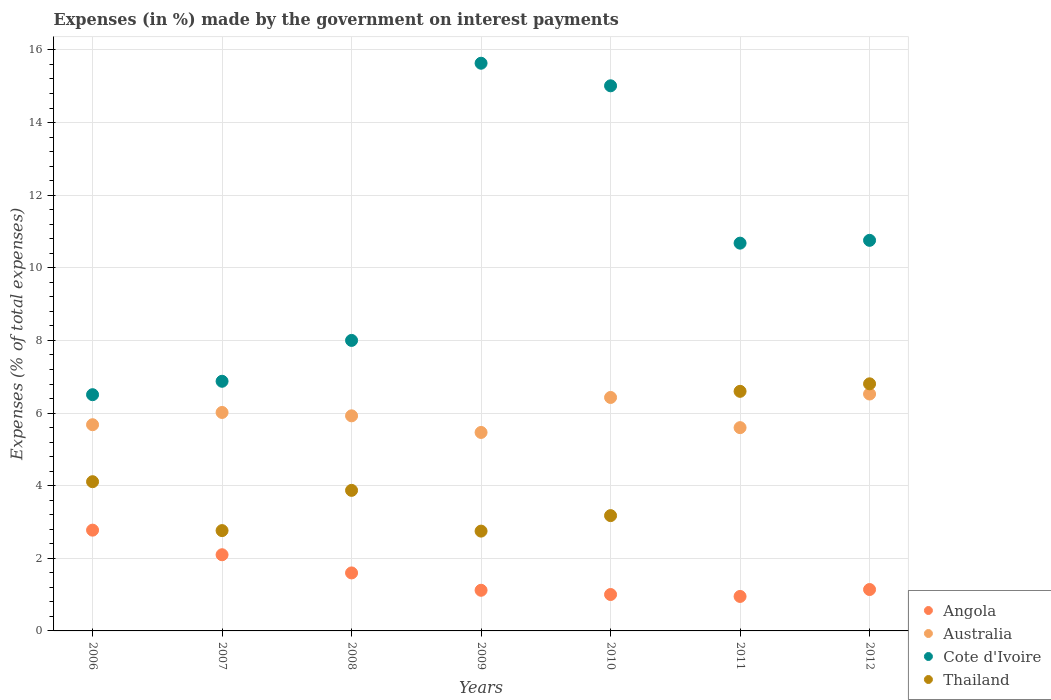How many different coloured dotlines are there?
Offer a terse response. 4. Is the number of dotlines equal to the number of legend labels?
Give a very brief answer. Yes. What is the percentage of expenses made by the government on interest payments in Thailand in 2007?
Ensure brevity in your answer.  2.76. Across all years, what is the maximum percentage of expenses made by the government on interest payments in Australia?
Provide a short and direct response. 6.52. Across all years, what is the minimum percentage of expenses made by the government on interest payments in Cote d'Ivoire?
Provide a succinct answer. 6.51. In which year was the percentage of expenses made by the government on interest payments in Cote d'Ivoire maximum?
Offer a very short reply. 2009. What is the total percentage of expenses made by the government on interest payments in Australia in the graph?
Make the answer very short. 41.64. What is the difference between the percentage of expenses made by the government on interest payments in Cote d'Ivoire in 2008 and that in 2011?
Offer a terse response. -2.68. What is the difference between the percentage of expenses made by the government on interest payments in Cote d'Ivoire in 2011 and the percentage of expenses made by the government on interest payments in Angola in 2012?
Your response must be concise. 9.54. What is the average percentage of expenses made by the government on interest payments in Thailand per year?
Provide a short and direct response. 4.3. In the year 2008, what is the difference between the percentage of expenses made by the government on interest payments in Angola and percentage of expenses made by the government on interest payments in Thailand?
Give a very brief answer. -2.27. In how many years, is the percentage of expenses made by the government on interest payments in Angola greater than 6.8 %?
Your answer should be very brief. 0. What is the ratio of the percentage of expenses made by the government on interest payments in Cote d'Ivoire in 2011 to that in 2012?
Ensure brevity in your answer.  0.99. What is the difference between the highest and the second highest percentage of expenses made by the government on interest payments in Cote d'Ivoire?
Ensure brevity in your answer.  0.62. What is the difference between the highest and the lowest percentage of expenses made by the government on interest payments in Cote d'Ivoire?
Give a very brief answer. 9.13. In how many years, is the percentage of expenses made by the government on interest payments in Thailand greater than the average percentage of expenses made by the government on interest payments in Thailand taken over all years?
Give a very brief answer. 2. Is it the case that in every year, the sum of the percentage of expenses made by the government on interest payments in Cote d'Ivoire and percentage of expenses made by the government on interest payments in Thailand  is greater than the sum of percentage of expenses made by the government on interest payments in Australia and percentage of expenses made by the government on interest payments in Angola?
Offer a very short reply. Yes. Does the percentage of expenses made by the government on interest payments in Australia monotonically increase over the years?
Your response must be concise. No. How many dotlines are there?
Give a very brief answer. 4. Are the values on the major ticks of Y-axis written in scientific E-notation?
Make the answer very short. No. What is the title of the graph?
Make the answer very short. Expenses (in %) made by the government on interest payments. Does "Angola" appear as one of the legend labels in the graph?
Your response must be concise. Yes. What is the label or title of the X-axis?
Give a very brief answer. Years. What is the label or title of the Y-axis?
Provide a short and direct response. Expenses (% of total expenses). What is the Expenses (% of total expenses) in Angola in 2006?
Keep it short and to the point. 2.78. What is the Expenses (% of total expenses) of Australia in 2006?
Keep it short and to the point. 5.68. What is the Expenses (% of total expenses) of Cote d'Ivoire in 2006?
Your response must be concise. 6.51. What is the Expenses (% of total expenses) in Thailand in 2006?
Your response must be concise. 4.11. What is the Expenses (% of total expenses) of Angola in 2007?
Your answer should be very brief. 2.1. What is the Expenses (% of total expenses) of Australia in 2007?
Ensure brevity in your answer.  6.02. What is the Expenses (% of total expenses) in Cote d'Ivoire in 2007?
Provide a short and direct response. 6.88. What is the Expenses (% of total expenses) of Thailand in 2007?
Offer a very short reply. 2.76. What is the Expenses (% of total expenses) of Angola in 2008?
Give a very brief answer. 1.6. What is the Expenses (% of total expenses) of Australia in 2008?
Ensure brevity in your answer.  5.92. What is the Expenses (% of total expenses) in Cote d'Ivoire in 2008?
Your answer should be compact. 8. What is the Expenses (% of total expenses) of Thailand in 2008?
Provide a succinct answer. 3.87. What is the Expenses (% of total expenses) of Angola in 2009?
Provide a short and direct response. 1.12. What is the Expenses (% of total expenses) in Australia in 2009?
Provide a short and direct response. 5.47. What is the Expenses (% of total expenses) in Cote d'Ivoire in 2009?
Make the answer very short. 15.63. What is the Expenses (% of total expenses) in Thailand in 2009?
Your answer should be compact. 2.75. What is the Expenses (% of total expenses) of Angola in 2010?
Provide a succinct answer. 1. What is the Expenses (% of total expenses) in Australia in 2010?
Ensure brevity in your answer.  6.43. What is the Expenses (% of total expenses) in Cote d'Ivoire in 2010?
Keep it short and to the point. 15.01. What is the Expenses (% of total expenses) of Thailand in 2010?
Ensure brevity in your answer.  3.18. What is the Expenses (% of total expenses) of Angola in 2011?
Your answer should be compact. 0.95. What is the Expenses (% of total expenses) in Australia in 2011?
Provide a succinct answer. 5.6. What is the Expenses (% of total expenses) of Cote d'Ivoire in 2011?
Offer a very short reply. 10.68. What is the Expenses (% of total expenses) of Thailand in 2011?
Make the answer very short. 6.6. What is the Expenses (% of total expenses) of Angola in 2012?
Keep it short and to the point. 1.14. What is the Expenses (% of total expenses) in Australia in 2012?
Give a very brief answer. 6.52. What is the Expenses (% of total expenses) of Cote d'Ivoire in 2012?
Make the answer very short. 10.76. What is the Expenses (% of total expenses) of Thailand in 2012?
Your answer should be compact. 6.81. Across all years, what is the maximum Expenses (% of total expenses) of Angola?
Keep it short and to the point. 2.78. Across all years, what is the maximum Expenses (% of total expenses) in Australia?
Offer a terse response. 6.52. Across all years, what is the maximum Expenses (% of total expenses) in Cote d'Ivoire?
Ensure brevity in your answer.  15.63. Across all years, what is the maximum Expenses (% of total expenses) in Thailand?
Keep it short and to the point. 6.81. Across all years, what is the minimum Expenses (% of total expenses) of Angola?
Provide a short and direct response. 0.95. Across all years, what is the minimum Expenses (% of total expenses) in Australia?
Give a very brief answer. 5.47. Across all years, what is the minimum Expenses (% of total expenses) in Cote d'Ivoire?
Your answer should be very brief. 6.51. Across all years, what is the minimum Expenses (% of total expenses) in Thailand?
Your response must be concise. 2.75. What is the total Expenses (% of total expenses) of Angola in the graph?
Your answer should be very brief. 10.68. What is the total Expenses (% of total expenses) of Australia in the graph?
Make the answer very short. 41.64. What is the total Expenses (% of total expenses) of Cote d'Ivoire in the graph?
Provide a short and direct response. 73.46. What is the total Expenses (% of total expenses) in Thailand in the graph?
Provide a short and direct response. 30.07. What is the difference between the Expenses (% of total expenses) of Angola in 2006 and that in 2007?
Offer a very short reply. 0.68. What is the difference between the Expenses (% of total expenses) of Australia in 2006 and that in 2007?
Make the answer very short. -0.34. What is the difference between the Expenses (% of total expenses) of Cote d'Ivoire in 2006 and that in 2007?
Give a very brief answer. -0.37. What is the difference between the Expenses (% of total expenses) of Thailand in 2006 and that in 2007?
Your answer should be compact. 1.35. What is the difference between the Expenses (% of total expenses) in Angola in 2006 and that in 2008?
Your answer should be compact. 1.18. What is the difference between the Expenses (% of total expenses) in Australia in 2006 and that in 2008?
Provide a succinct answer. -0.24. What is the difference between the Expenses (% of total expenses) in Cote d'Ivoire in 2006 and that in 2008?
Provide a short and direct response. -1.49. What is the difference between the Expenses (% of total expenses) in Thailand in 2006 and that in 2008?
Offer a very short reply. 0.24. What is the difference between the Expenses (% of total expenses) of Angola in 2006 and that in 2009?
Your response must be concise. 1.66. What is the difference between the Expenses (% of total expenses) of Australia in 2006 and that in 2009?
Your answer should be very brief. 0.21. What is the difference between the Expenses (% of total expenses) in Cote d'Ivoire in 2006 and that in 2009?
Provide a succinct answer. -9.13. What is the difference between the Expenses (% of total expenses) of Thailand in 2006 and that in 2009?
Your answer should be compact. 1.36. What is the difference between the Expenses (% of total expenses) in Angola in 2006 and that in 2010?
Provide a succinct answer. 1.77. What is the difference between the Expenses (% of total expenses) of Australia in 2006 and that in 2010?
Offer a very short reply. -0.75. What is the difference between the Expenses (% of total expenses) of Cote d'Ivoire in 2006 and that in 2010?
Keep it short and to the point. -8.51. What is the difference between the Expenses (% of total expenses) of Thailand in 2006 and that in 2010?
Your answer should be compact. 0.93. What is the difference between the Expenses (% of total expenses) of Angola in 2006 and that in 2011?
Your answer should be very brief. 1.83. What is the difference between the Expenses (% of total expenses) of Australia in 2006 and that in 2011?
Offer a very short reply. 0.08. What is the difference between the Expenses (% of total expenses) in Cote d'Ivoire in 2006 and that in 2011?
Ensure brevity in your answer.  -4.17. What is the difference between the Expenses (% of total expenses) of Thailand in 2006 and that in 2011?
Ensure brevity in your answer.  -2.49. What is the difference between the Expenses (% of total expenses) of Angola in 2006 and that in 2012?
Ensure brevity in your answer.  1.64. What is the difference between the Expenses (% of total expenses) in Australia in 2006 and that in 2012?
Keep it short and to the point. -0.85. What is the difference between the Expenses (% of total expenses) of Cote d'Ivoire in 2006 and that in 2012?
Make the answer very short. -4.25. What is the difference between the Expenses (% of total expenses) in Thailand in 2006 and that in 2012?
Ensure brevity in your answer.  -2.7. What is the difference between the Expenses (% of total expenses) in Angola in 2007 and that in 2008?
Provide a succinct answer. 0.5. What is the difference between the Expenses (% of total expenses) in Australia in 2007 and that in 2008?
Provide a short and direct response. 0.09. What is the difference between the Expenses (% of total expenses) in Cote d'Ivoire in 2007 and that in 2008?
Your answer should be very brief. -1.13. What is the difference between the Expenses (% of total expenses) of Thailand in 2007 and that in 2008?
Your answer should be very brief. -1.11. What is the difference between the Expenses (% of total expenses) in Angola in 2007 and that in 2009?
Make the answer very short. 0.98. What is the difference between the Expenses (% of total expenses) in Australia in 2007 and that in 2009?
Your answer should be very brief. 0.55. What is the difference between the Expenses (% of total expenses) in Cote d'Ivoire in 2007 and that in 2009?
Your answer should be very brief. -8.76. What is the difference between the Expenses (% of total expenses) of Thailand in 2007 and that in 2009?
Offer a terse response. 0.01. What is the difference between the Expenses (% of total expenses) of Angola in 2007 and that in 2010?
Give a very brief answer. 1.1. What is the difference between the Expenses (% of total expenses) of Australia in 2007 and that in 2010?
Your answer should be compact. -0.41. What is the difference between the Expenses (% of total expenses) of Cote d'Ivoire in 2007 and that in 2010?
Your response must be concise. -8.14. What is the difference between the Expenses (% of total expenses) of Thailand in 2007 and that in 2010?
Your response must be concise. -0.41. What is the difference between the Expenses (% of total expenses) in Angola in 2007 and that in 2011?
Offer a terse response. 1.15. What is the difference between the Expenses (% of total expenses) of Australia in 2007 and that in 2011?
Offer a very short reply. 0.42. What is the difference between the Expenses (% of total expenses) in Cote d'Ivoire in 2007 and that in 2011?
Offer a terse response. -3.8. What is the difference between the Expenses (% of total expenses) of Thailand in 2007 and that in 2011?
Ensure brevity in your answer.  -3.84. What is the difference between the Expenses (% of total expenses) in Angola in 2007 and that in 2012?
Offer a terse response. 0.96. What is the difference between the Expenses (% of total expenses) in Australia in 2007 and that in 2012?
Make the answer very short. -0.51. What is the difference between the Expenses (% of total expenses) of Cote d'Ivoire in 2007 and that in 2012?
Provide a short and direct response. -3.88. What is the difference between the Expenses (% of total expenses) of Thailand in 2007 and that in 2012?
Your answer should be compact. -4.04. What is the difference between the Expenses (% of total expenses) of Angola in 2008 and that in 2009?
Your answer should be compact. 0.48. What is the difference between the Expenses (% of total expenses) of Australia in 2008 and that in 2009?
Offer a very short reply. 0.46. What is the difference between the Expenses (% of total expenses) in Cote d'Ivoire in 2008 and that in 2009?
Your response must be concise. -7.63. What is the difference between the Expenses (% of total expenses) in Thailand in 2008 and that in 2009?
Ensure brevity in your answer.  1.12. What is the difference between the Expenses (% of total expenses) of Angola in 2008 and that in 2010?
Offer a terse response. 0.59. What is the difference between the Expenses (% of total expenses) of Australia in 2008 and that in 2010?
Your answer should be very brief. -0.51. What is the difference between the Expenses (% of total expenses) of Cote d'Ivoire in 2008 and that in 2010?
Your answer should be very brief. -7.01. What is the difference between the Expenses (% of total expenses) in Thailand in 2008 and that in 2010?
Your response must be concise. 0.7. What is the difference between the Expenses (% of total expenses) in Angola in 2008 and that in 2011?
Your answer should be compact. 0.65. What is the difference between the Expenses (% of total expenses) in Australia in 2008 and that in 2011?
Give a very brief answer. 0.33. What is the difference between the Expenses (% of total expenses) in Cote d'Ivoire in 2008 and that in 2011?
Give a very brief answer. -2.68. What is the difference between the Expenses (% of total expenses) in Thailand in 2008 and that in 2011?
Give a very brief answer. -2.73. What is the difference between the Expenses (% of total expenses) of Angola in 2008 and that in 2012?
Your response must be concise. 0.46. What is the difference between the Expenses (% of total expenses) of Australia in 2008 and that in 2012?
Your response must be concise. -0.6. What is the difference between the Expenses (% of total expenses) of Cote d'Ivoire in 2008 and that in 2012?
Give a very brief answer. -2.76. What is the difference between the Expenses (% of total expenses) of Thailand in 2008 and that in 2012?
Your answer should be very brief. -2.93. What is the difference between the Expenses (% of total expenses) in Angola in 2009 and that in 2010?
Keep it short and to the point. 0.12. What is the difference between the Expenses (% of total expenses) in Australia in 2009 and that in 2010?
Provide a succinct answer. -0.96. What is the difference between the Expenses (% of total expenses) of Cote d'Ivoire in 2009 and that in 2010?
Ensure brevity in your answer.  0.62. What is the difference between the Expenses (% of total expenses) in Thailand in 2009 and that in 2010?
Your answer should be very brief. -0.43. What is the difference between the Expenses (% of total expenses) in Angola in 2009 and that in 2011?
Your response must be concise. 0.17. What is the difference between the Expenses (% of total expenses) in Australia in 2009 and that in 2011?
Your answer should be very brief. -0.13. What is the difference between the Expenses (% of total expenses) of Cote d'Ivoire in 2009 and that in 2011?
Provide a succinct answer. 4.95. What is the difference between the Expenses (% of total expenses) of Thailand in 2009 and that in 2011?
Your response must be concise. -3.85. What is the difference between the Expenses (% of total expenses) of Angola in 2009 and that in 2012?
Your response must be concise. -0.02. What is the difference between the Expenses (% of total expenses) in Australia in 2009 and that in 2012?
Your answer should be very brief. -1.06. What is the difference between the Expenses (% of total expenses) in Cote d'Ivoire in 2009 and that in 2012?
Your response must be concise. 4.88. What is the difference between the Expenses (% of total expenses) in Thailand in 2009 and that in 2012?
Provide a short and direct response. -4.06. What is the difference between the Expenses (% of total expenses) of Angola in 2010 and that in 2011?
Provide a short and direct response. 0.05. What is the difference between the Expenses (% of total expenses) of Australia in 2010 and that in 2011?
Give a very brief answer. 0.83. What is the difference between the Expenses (% of total expenses) in Cote d'Ivoire in 2010 and that in 2011?
Provide a succinct answer. 4.33. What is the difference between the Expenses (% of total expenses) of Thailand in 2010 and that in 2011?
Your response must be concise. -3.42. What is the difference between the Expenses (% of total expenses) in Angola in 2010 and that in 2012?
Give a very brief answer. -0.14. What is the difference between the Expenses (% of total expenses) of Australia in 2010 and that in 2012?
Offer a very short reply. -0.1. What is the difference between the Expenses (% of total expenses) of Cote d'Ivoire in 2010 and that in 2012?
Your response must be concise. 4.26. What is the difference between the Expenses (% of total expenses) in Thailand in 2010 and that in 2012?
Provide a succinct answer. -3.63. What is the difference between the Expenses (% of total expenses) of Angola in 2011 and that in 2012?
Offer a terse response. -0.19. What is the difference between the Expenses (% of total expenses) in Australia in 2011 and that in 2012?
Your answer should be very brief. -0.93. What is the difference between the Expenses (% of total expenses) of Cote d'Ivoire in 2011 and that in 2012?
Offer a terse response. -0.08. What is the difference between the Expenses (% of total expenses) in Thailand in 2011 and that in 2012?
Give a very brief answer. -0.21. What is the difference between the Expenses (% of total expenses) of Angola in 2006 and the Expenses (% of total expenses) of Australia in 2007?
Your answer should be very brief. -3.24. What is the difference between the Expenses (% of total expenses) in Angola in 2006 and the Expenses (% of total expenses) in Cote d'Ivoire in 2007?
Give a very brief answer. -4.1. What is the difference between the Expenses (% of total expenses) in Angola in 2006 and the Expenses (% of total expenses) in Thailand in 2007?
Offer a very short reply. 0.01. What is the difference between the Expenses (% of total expenses) in Australia in 2006 and the Expenses (% of total expenses) in Cote d'Ivoire in 2007?
Your answer should be very brief. -1.2. What is the difference between the Expenses (% of total expenses) in Australia in 2006 and the Expenses (% of total expenses) in Thailand in 2007?
Make the answer very short. 2.92. What is the difference between the Expenses (% of total expenses) in Cote d'Ivoire in 2006 and the Expenses (% of total expenses) in Thailand in 2007?
Offer a very short reply. 3.74. What is the difference between the Expenses (% of total expenses) in Angola in 2006 and the Expenses (% of total expenses) in Australia in 2008?
Offer a terse response. -3.15. What is the difference between the Expenses (% of total expenses) of Angola in 2006 and the Expenses (% of total expenses) of Cote d'Ivoire in 2008?
Offer a very short reply. -5.23. What is the difference between the Expenses (% of total expenses) in Angola in 2006 and the Expenses (% of total expenses) in Thailand in 2008?
Your answer should be very brief. -1.1. What is the difference between the Expenses (% of total expenses) in Australia in 2006 and the Expenses (% of total expenses) in Cote d'Ivoire in 2008?
Your answer should be very brief. -2.32. What is the difference between the Expenses (% of total expenses) of Australia in 2006 and the Expenses (% of total expenses) of Thailand in 2008?
Give a very brief answer. 1.81. What is the difference between the Expenses (% of total expenses) of Cote d'Ivoire in 2006 and the Expenses (% of total expenses) of Thailand in 2008?
Make the answer very short. 2.63. What is the difference between the Expenses (% of total expenses) of Angola in 2006 and the Expenses (% of total expenses) of Australia in 2009?
Ensure brevity in your answer.  -2.69. What is the difference between the Expenses (% of total expenses) in Angola in 2006 and the Expenses (% of total expenses) in Cote d'Ivoire in 2009?
Ensure brevity in your answer.  -12.86. What is the difference between the Expenses (% of total expenses) in Angola in 2006 and the Expenses (% of total expenses) in Thailand in 2009?
Keep it short and to the point. 0.03. What is the difference between the Expenses (% of total expenses) in Australia in 2006 and the Expenses (% of total expenses) in Cote d'Ivoire in 2009?
Offer a very short reply. -9.96. What is the difference between the Expenses (% of total expenses) in Australia in 2006 and the Expenses (% of total expenses) in Thailand in 2009?
Give a very brief answer. 2.93. What is the difference between the Expenses (% of total expenses) in Cote d'Ivoire in 2006 and the Expenses (% of total expenses) in Thailand in 2009?
Provide a succinct answer. 3.76. What is the difference between the Expenses (% of total expenses) of Angola in 2006 and the Expenses (% of total expenses) of Australia in 2010?
Ensure brevity in your answer.  -3.65. What is the difference between the Expenses (% of total expenses) of Angola in 2006 and the Expenses (% of total expenses) of Cote d'Ivoire in 2010?
Your response must be concise. -12.24. What is the difference between the Expenses (% of total expenses) of Angola in 2006 and the Expenses (% of total expenses) of Thailand in 2010?
Provide a short and direct response. -0.4. What is the difference between the Expenses (% of total expenses) of Australia in 2006 and the Expenses (% of total expenses) of Cote d'Ivoire in 2010?
Your answer should be very brief. -9.33. What is the difference between the Expenses (% of total expenses) in Australia in 2006 and the Expenses (% of total expenses) in Thailand in 2010?
Keep it short and to the point. 2.5. What is the difference between the Expenses (% of total expenses) of Cote d'Ivoire in 2006 and the Expenses (% of total expenses) of Thailand in 2010?
Keep it short and to the point. 3.33. What is the difference between the Expenses (% of total expenses) in Angola in 2006 and the Expenses (% of total expenses) in Australia in 2011?
Offer a very short reply. -2.82. What is the difference between the Expenses (% of total expenses) of Angola in 2006 and the Expenses (% of total expenses) of Cote d'Ivoire in 2011?
Your answer should be very brief. -7.9. What is the difference between the Expenses (% of total expenses) of Angola in 2006 and the Expenses (% of total expenses) of Thailand in 2011?
Give a very brief answer. -3.82. What is the difference between the Expenses (% of total expenses) in Australia in 2006 and the Expenses (% of total expenses) in Cote d'Ivoire in 2011?
Offer a terse response. -5. What is the difference between the Expenses (% of total expenses) in Australia in 2006 and the Expenses (% of total expenses) in Thailand in 2011?
Give a very brief answer. -0.92. What is the difference between the Expenses (% of total expenses) in Cote d'Ivoire in 2006 and the Expenses (% of total expenses) in Thailand in 2011?
Offer a terse response. -0.09. What is the difference between the Expenses (% of total expenses) of Angola in 2006 and the Expenses (% of total expenses) of Australia in 2012?
Your answer should be very brief. -3.75. What is the difference between the Expenses (% of total expenses) in Angola in 2006 and the Expenses (% of total expenses) in Cote d'Ivoire in 2012?
Offer a terse response. -7.98. What is the difference between the Expenses (% of total expenses) in Angola in 2006 and the Expenses (% of total expenses) in Thailand in 2012?
Provide a short and direct response. -4.03. What is the difference between the Expenses (% of total expenses) of Australia in 2006 and the Expenses (% of total expenses) of Cote d'Ivoire in 2012?
Your answer should be very brief. -5.08. What is the difference between the Expenses (% of total expenses) of Australia in 2006 and the Expenses (% of total expenses) of Thailand in 2012?
Make the answer very short. -1.13. What is the difference between the Expenses (% of total expenses) in Cote d'Ivoire in 2006 and the Expenses (% of total expenses) in Thailand in 2012?
Offer a terse response. -0.3. What is the difference between the Expenses (% of total expenses) of Angola in 2007 and the Expenses (% of total expenses) of Australia in 2008?
Offer a very short reply. -3.83. What is the difference between the Expenses (% of total expenses) of Angola in 2007 and the Expenses (% of total expenses) of Cote d'Ivoire in 2008?
Keep it short and to the point. -5.9. What is the difference between the Expenses (% of total expenses) in Angola in 2007 and the Expenses (% of total expenses) in Thailand in 2008?
Your answer should be very brief. -1.77. What is the difference between the Expenses (% of total expenses) of Australia in 2007 and the Expenses (% of total expenses) of Cote d'Ivoire in 2008?
Your answer should be compact. -1.98. What is the difference between the Expenses (% of total expenses) of Australia in 2007 and the Expenses (% of total expenses) of Thailand in 2008?
Ensure brevity in your answer.  2.15. What is the difference between the Expenses (% of total expenses) in Cote d'Ivoire in 2007 and the Expenses (% of total expenses) in Thailand in 2008?
Keep it short and to the point. 3. What is the difference between the Expenses (% of total expenses) of Angola in 2007 and the Expenses (% of total expenses) of Australia in 2009?
Provide a short and direct response. -3.37. What is the difference between the Expenses (% of total expenses) in Angola in 2007 and the Expenses (% of total expenses) in Cote d'Ivoire in 2009?
Provide a short and direct response. -13.54. What is the difference between the Expenses (% of total expenses) of Angola in 2007 and the Expenses (% of total expenses) of Thailand in 2009?
Your answer should be compact. -0.65. What is the difference between the Expenses (% of total expenses) in Australia in 2007 and the Expenses (% of total expenses) in Cote d'Ivoire in 2009?
Your answer should be compact. -9.62. What is the difference between the Expenses (% of total expenses) of Australia in 2007 and the Expenses (% of total expenses) of Thailand in 2009?
Provide a succinct answer. 3.27. What is the difference between the Expenses (% of total expenses) of Cote d'Ivoire in 2007 and the Expenses (% of total expenses) of Thailand in 2009?
Provide a short and direct response. 4.13. What is the difference between the Expenses (% of total expenses) in Angola in 2007 and the Expenses (% of total expenses) in Australia in 2010?
Keep it short and to the point. -4.33. What is the difference between the Expenses (% of total expenses) in Angola in 2007 and the Expenses (% of total expenses) in Cote d'Ivoire in 2010?
Offer a very short reply. -12.91. What is the difference between the Expenses (% of total expenses) in Angola in 2007 and the Expenses (% of total expenses) in Thailand in 2010?
Ensure brevity in your answer.  -1.08. What is the difference between the Expenses (% of total expenses) of Australia in 2007 and the Expenses (% of total expenses) of Cote d'Ivoire in 2010?
Offer a very short reply. -9. What is the difference between the Expenses (% of total expenses) of Australia in 2007 and the Expenses (% of total expenses) of Thailand in 2010?
Ensure brevity in your answer.  2.84. What is the difference between the Expenses (% of total expenses) of Cote d'Ivoire in 2007 and the Expenses (% of total expenses) of Thailand in 2010?
Offer a very short reply. 3.7. What is the difference between the Expenses (% of total expenses) of Angola in 2007 and the Expenses (% of total expenses) of Australia in 2011?
Your response must be concise. -3.5. What is the difference between the Expenses (% of total expenses) of Angola in 2007 and the Expenses (% of total expenses) of Cote d'Ivoire in 2011?
Offer a terse response. -8.58. What is the difference between the Expenses (% of total expenses) of Angola in 2007 and the Expenses (% of total expenses) of Thailand in 2011?
Give a very brief answer. -4.5. What is the difference between the Expenses (% of total expenses) in Australia in 2007 and the Expenses (% of total expenses) in Cote d'Ivoire in 2011?
Your answer should be very brief. -4.66. What is the difference between the Expenses (% of total expenses) of Australia in 2007 and the Expenses (% of total expenses) of Thailand in 2011?
Your answer should be very brief. -0.58. What is the difference between the Expenses (% of total expenses) of Cote d'Ivoire in 2007 and the Expenses (% of total expenses) of Thailand in 2011?
Offer a very short reply. 0.28. What is the difference between the Expenses (% of total expenses) of Angola in 2007 and the Expenses (% of total expenses) of Australia in 2012?
Ensure brevity in your answer.  -4.43. What is the difference between the Expenses (% of total expenses) of Angola in 2007 and the Expenses (% of total expenses) of Cote d'Ivoire in 2012?
Give a very brief answer. -8.66. What is the difference between the Expenses (% of total expenses) in Angola in 2007 and the Expenses (% of total expenses) in Thailand in 2012?
Offer a terse response. -4.71. What is the difference between the Expenses (% of total expenses) of Australia in 2007 and the Expenses (% of total expenses) of Cote d'Ivoire in 2012?
Your answer should be compact. -4.74. What is the difference between the Expenses (% of total expenses) of Australia in 2007 and the Expenses (% of total expenses) of Thailand in 2012?
Your response must be concise. -0.79. What is the difference between the Expenses (% of total expenses) of Cote d'Ivoire in 2007 and the Expenses (% of total expenses) of Thailand in 2012?
Offer a terse response. 0.07. What is the difference between the Expenses (% of total expenses) of Angola in 2008 and the Expenses (% of total expenses) of Australia in 2009?
Offer a very short reply. -3.87. What is the difference between the Expenses (% of total expenses) in Angola in 2008 and the Expenses (% of total expenses) in Cote d'Ivoire in 2009?
Your answer should be compact. -14.04. What is the difference between the Expenses (% of total expenses) in Angola in 2008 and the Expenses (% of total expenses) in Thailand in 2009?
Offer a terse response. -1.15. What is the difference between the Expenses (% of total expenses) of Australia in 2008 and the Expenses (% of total expenses) of Cote d'Ivoire in 2009?
Offer a very short reply. -9.71. What is the difference between the Expenses (% of total expenses) of Australia in 2008 and the Expenses (% of total expenses) of Thailand in 2009?
Give a very brief answer. 3.17. What is the difference between the Expenses (% of total expenses) in Cote d'Ivoire in 2008 and the Expenses (% of total expenses) in Thailand in 2009?
Give a very brief answer. 5.25. What is the difference between the Expenses (% of total expenses) of Angola in 2008 and the Expenses (% of total expenses) of Australia in 2010?
Offer a terse response. -4.83. What is the difference between the Expenses (% of total expenses) of Angola in 2008 and the Expenses (% of total expenses) of Cote d'Ivoire in 2010?
Make the answer very short. -13.42. What is the difference between the Expenses (% of total expenses) in Angola in 2008 and the Expenses (% of total expenses) in Thailand in 2010?
Your answer should be compact. -1.58. What is the difference between the Expenses (% of total expenses) of Australia in 2008 and the Expenses (% of total expenses) of Cote d'Ivoire in 2010?
Your answer should be very brief. -9.09. What is the difference between the Expenses (% of total expenses) in Australia in 2008 and the Expenses (% of total expenses) in Thailand in 2010?
Make the answer very short. 2.75. What is the difference between the Expenses (% of total expenses) in Cote d'Ivoire in 2008 and the Expenses (% of total expenses) in Thailand in 2010?
Make the answer very short. 4.83. What is the difference between the Expenses (% of total expenses) in Angola in 2008 and the Expenses (% of total expenses) in Australia in 2011?
Your response must be concise. -4. What is the difference between the Expenses (% of total expenses) in Angola in 2008 and the Expenses (% of total expenses) in Cote d'Ivoire in 2011?
Offer a very short reply. -9.08. What is the difference between the Expenses (% of total expenses) in Angola in 2008 and the Expenses (% of total expenses) in Thailand in 2011?
Offer a very short reply. -5. What is the difference between the Expenses (% of total expenses) in Australia in 2008 and the Expenses (% of total expenses) in Cote d'Ivoire in 2011?
Ensure brevity in your answer.  -4.76. What is the difference between the Expenses (% of total expenses) of Australia in 2008 and the Expenses (% of total expenses) of Thailand in 2011?
Ensure brevity in your answer.  -0.67. What is the difference between the Expenses (% of total expenses) of Cote d'Ivoire in 2008 and the Expenses (% of total expenses) of Thailand in 2011?
Your answer should be compact. 1.4. What is the difference between the Expenses (% of total expenses) in Angola in 2008 and the Expenses (% of total expenses) in Australia in 2012?
Ensure brevity in your answer.  -4.93. What is the difference between the Expenses (% of total expenses) of Angola in 2008 and the Expenses (% of total expenses) of Cote d'Ivoire in 2012?
Offer a very short reply. -9.16. What is the difference between the Expenses (% of total expenses) in Angola in 2008 and the Expenses (% of total expenses) in Thailand in 2012?
Ensure brevity in your answer.  -5.21. What is the difference between the Expenses (% of total expenses) in Australia in 2008 and the Expenses (% of total expenses) in Cote d'Ivoire in 2012?
Your answer should be compact. -4.83. What is the difference between the Expenses (% of total expenses) of Australia in 2008 and the Expenses (% of total expenses) of Thailand in 2012?
Your answer should be very brief. -0.88. What is the difference between the Expenses (% of total expenses) of Cote d'Ivoire in 2008 and the Expenses (% of total expenses) of Thailand in 2012?
Your response must be concise. 1.2. What is the difference between the Expenses (% of total expenses) in Angola in 2009 and the Expenses (% of total expenses) in Australia in 2010?
Ensure brevity in your answer.  -5.31. What is the difference between the Expenses (% of total expenses) of Angola in 2009 and the Expenses (% of total expenses) of Cote d'Ivoire in 2010?
Offer a very short reply. -13.89. What is the difference between the Expenses (% of total expenses) of Angola in 2009 and the Expenses (% of total expenses) of Thailand in 2010?
Ensure brevity in your answer.  -2.06. What is the difference between the Expenses (% of total expenses) of Australia in 2009 and the Expenses (% of total expenses) of Cote d'Ivoire in 2010?
Your response must be concise. -9.55. What is the difference between the Expenses (% of total expenses) of Australia in 2009 and the Expenses (% of total expenses) of Thailand in 2010?
Provide a short and direct response. 2.29. What is the difference between the Expenses (% of total expenses) in Cote d'Ivoire in 2009 and the Expenses (% of total expenses) in Thailand in 2010?
Your answer should be very brief. 12.46. What is the difference between the Expenses (% of total expenses) of Angola in 2009 and the Expenses (% of total expenses) of Australia in 2011?
Your response must be concise. -4.48. What is the difference between the Expenses (% of total expenses) in Angola in 2009 and the Expenses (% of total expenses) in Cote d'Ivoire in 2011?
Your response must be concise. -9.56. What is the difference between the Expenses (% of total expenses) in Angola in 2009 and the Expenses (% of total expenses) in Thailand in 2011?
Keep it short and to the point. -5.48. What is the difference between the Expenses (% of total expenses) of Australia in 2009 and the Expenses (% of total expenses) of Cote d'Ivoire in 2011?
Your answer should be very brief. -5.21. What is the difference between the Expenses (% of total expenses) in Australia in 2009 and the Expenses (% of total expenses) in Thailand in 2011?
Give a very brief answer. -1.13. What is the difference between the Expenses (% of total expenses) in Cote d'Ivoire in 2009 and the Expenses (% of total expenses) in Thailand in 2011?
Offer a terse response. 9.04. What is the difference between the Expenses (% of total expenses) of Angola in 2009 and the Expenses (% of total expenses) of Australia in 2012?
Give a very brief answer. -5.41. What is the difference between the Expenses (% of total expenses) in Angola in 2009 and the Expenses (% of total expenses) in Cote d'Ivoire in 2012?
Offer a very short reply. -9.64. What is the difference between the Expenses (% of total expenses) of Angola in 2009 and the Expenses (% of total expenses) of Thailand in 2012?
Offer a terse response. -5.69. What is the difference between the Expenses (% of total expenses) of Australia in 2009 and the Expenses (% of total expenses) of Cote d'Ivoire in 2012?
Provide a succinct answer. -5.29. What is the difference between the Expenses (% of total expenses) of Australia in 2009 and the Expenses (% of total expenses) of Thailand in 2012?
Your response must be concise. -1.34. What is the difference between the Expenses (% of total expenses) of Cote d'Ivoire in 2009 and the Expenses (% of total expenses) of Thailand in 2012?
Offer a very short reply. 8.83. What is the difference between the Expenses (% of total expenses) of Angola in 2010 and the Expenses (% of total expenses) of Australia in 2011?
Offer a very short reply. -4.6. What is the difference between the Expenses (% of total expenses) of Angola in 2010 and the Expenses (% of total expenses) of Cote d'Ivoire in 2011?
Your response must be concise. -9.68. What is the difference between the Expenses (% of total expenses) in Angola in 2010 and the Expenses (% of total expenses) in Thailand in 2011?
Keep it short and to the point. -5.6. What is the difference between the Expenses (% of total expenses) of Australia in 2010 and the Expenses (% of total expenses) of Cote d'Ivoire in 2011?
Make the answer very short. -4.25. What is the difference between the Expenses (% of total expenses) in Australia in 2010 and the Expenses (% of total expenses) in Thailand in 2011?
Keep it short and to the point. -0.17. What is the difference between the Expenses (% of total expenses) in Cote d'Ivoire in 2010 and the Expenses (% of total expenses) in Thailand in 2011?
Offer a very short reply. 8.41. What is the difference between the Expenses (% of total expenses) of Angola in 2010 and the Expenses (% of total expenses) of Australia in 2012?
Make the answer very short. -5.52. What is the difference between the Expenses (% of total expenses) of Angola in 2010 and the Expenses (% of total expenses) of Cote d'Ivoire in 2012?
Your answer should be very brief. -9.75. What is the difference between the Expenses (% of total expenses) of Angola in 2010 and the Expenses (% of total expenses) of Thailand in 2012?
Offer a very short reply. -5.8. What is the difference between the Expenses (% of total expenses) in Australia in 2010 and the Expenses (% of total expenses) in Cote d'Ivoire in 2012?
Provide a short and direct response. -4.33. What is the difference between the Expenses (% of total expenses) in Australia in 2010 and the Expenses (% of total expenses) in Thailand in 2012?
Provide a succinct answer. -0.38. What is the difference between the Expenses (% of total expenses) of Cote d'Ivoire in 2010 and the Expenses (% of total expenses) of Thailand in 2012?
Make the answer very short. 8.21. What is the difference between the Expenses (% of total expenses) in Angola in 2011 and the Expenses (% of total expenses) in Australia in 2012?
Your answer should be compact. -5.57. What is the difference between the Expenses (% of total expenses) of Angola in 2011 and the Expenses (% of total expenses) of Cote d'Ivoire in 2012?
Offer a terse response. -9.81. What is the difference between the Expenses (% of total expenses) of Angola in 2011 and the Expenses (% of total expenses) of Thailand in 2012?
Make the answer very short. -5.86. What is the difference between the Expenses (% of total expenses) in Australia in 2011 and the Expenses (% of total expenses) in Cote d'Ivoire in 2012?
Offer a very short reply. -5.16. What is the difference between the Expenses (% of total expenses) in Australia in 2011 and the Expenses (% of total expenses) in Thailand in 2012?
Ensure brevity in your answer.  -1.21. What is the difference between the Expenses (% of total expenses) in Cote d'Ivoire in 2011 and the Expenses (% of total expenses) in Thailand in 2012?
Your answer should be very brief. 3.87. What is the average Expenses (% of total expenses) of Angola per year?
Offer a terse response. 1.53. What is the average Expenses (% of total expenses) in Australia per year?
Your answer should be compact. 5.95. What is the average Expenses (% of total expenses) in Cote d'Ivoire per year?
Your answer should be compact. 10.49. What is the average Expenses (% of total expenses) in Thailand per year?
Make the answer very short. 4.3. In the year 2006, what is the difference between the Expenses (% of total expenses) in Angola and Expenses (% of total expenses) in Australia?
Your answer should be very brief. -2.9. In the year 2006, what is the difference between the Expenses (% of total expenses) in Angola and Expenses (% of total expenses) in Cote d'Ivoire?
Give a very brief answer. -3.73. In the year 2006, what is the difference between the Expenses (% of total expenses) of Angola and Expenses (% of total expenses) of Thailand?
Your response must be concise. -1.33. In the year 2006, what is the difference between the Expenses (% of total expenses) in Australia and Expenses (% of total expenses) in Cote d'Ivoire?
Provide a succinct answer. -0.83. In the year 2006, what is the difference between the Expenses (% of total expenses) of Australia and Expenses (% of total expenses) of Thailand?
Ensure brevity in your answer.  1.57. In the year 2006, what is the difference between the Expenses (% of total expenses) of Cote d'Ivoire and Expenses (% of total expenses) of Thailand?
Make the answer very short. 2.4. In the year 2007, what is the difference between the Expenses (% of total expenses) of Angola and Expenses (% of total expenses) of Australia?
Give a very brief answer. -3.92. In the year 2007, what is the difference between the Expenses (% of total expenses) in Angola and Expenses (% of total expenses) in Cote d'Ivoire?
Offer a very short reply. -4.78. In the year 2007, what is the difference between the Expenses (% of total expenses) in Angola and Expenses (% of total expenses) in Thailand?
Provide a succinct answer. -0.67. In the year 2007, what is the difference between the Expenses (% of total expenses) of Australia and Expenses (% of total expenses) of Cote d'Ivoire?
Your answer should be very brief. -0.86. In the year 2007, what is the difference between the Expenses (% of total expenses) of Australia and Expenses (% of total expenses) of Thailand?
Offer a terse response. 3.25. In the year 2007, what is the difference between the Expenses (% of total expenses) of Cote d'Ivoire and Expenses (% of total expenses) of Thailand?
Your answer should be very brief. 4.11. In the year 2008, what is the difference between the Expenses (% of total expenses) in Angola and Expenses (% of total expenses) in Australia?
Your answer should be compact. -4.33. In the year 2008, what is the difference between the Expenses (% of total expenses) in Angola and Expenses (% of total expenses) in Cote d'Ivoire?
Give a very brief answer. -6.4. In the year 2008, what is the difference between the Expenses (% of total expenses) of Angola and Expenses (% of total expenses) of Thailand?
Offer a terse response. -2.27. In the year 2008, what is the difference between the Expenses (% of total expenses) of Australia and Expenses (% of total expenses) of Cote d'Ivoire?
Offer a terse response. -2.08. In the year 2008, what is the difference between the Expenses (% of total expenses) of Australia and Expenses (% of total expenses) of Thailand?
Your answer should be very brief. 2.05. In the year 2008, what is the difference between the Expenses (% of total expenses) in Cote d'Ivoire and Expenses (% of total expenses) in Thailand?
Keep it short and to the point. 4.13. In the year 2009, what is the difference between the Expenses (% of total expenses) of Angola and Expenses (% of total expenses) of Australia?
Keep it short and to the point. -4.35. In the year 2009, what is the difference between the Expenses (% of total expenses) in Angola and Expenses (% of total expenses) in Cote d'Ivoire?
Make the answer very short. -14.51. In the year 2009, what is the difference between the Expenses (% of total expenses) of Angola and Expenses (% of total expenses) of Thailand?
Give a very brief answer. -1.63. In the year 2009, what is the difference between the Expenses (% of total expenses) in Australia and Expenses (% of total expenses) in Cote d'Ivoire?
Your answer should be very brief. -10.17. In the year 2009, what is the difference between the Expenses (% of total expenses) of Australia and Expenses (% of total expenses) of Thailand?
Offer a terse response. 2.72. In the year 2009, what is the difference between the Expenses (% of total expenses) in Cote d'Ivoire and Expenses (% of total expenses) in Thailand?
Provide a short and direct response. 12.89. In the year 2010, what is the difference between the Expenses (% of total expenses) of Angola and Expenses (% of total expenses) of Australia?
Keep it short and to the point. -5.43. In the year 2010, what is the difference between the Expenses (% of total expenses) in Angola and Expenses (% of total expenses) in Cote d'Ivoire?
Give a very brief answer. -14.01. In the year 2010, what is the difference between the Expenses (% of total expenses) in Angola and Expenses (% of total expenses) in Thailand?
Ensure brevity in your answer.  -2.17. In the year 2010, what is the difference between the Expenses (% of total expenses) in Australia and Expenses (% of total expenses) in Cote d'Ivoire?
Provide a short and direct response. -8.58. In the year 2010, what is the difference between the Expenses (% of total expenses) of Australia and Expenses (% of total expenses) of Thailand?
Offer a very short reply. 3.25. In the year 2010, what is the difference between the Expenses (% of total expenses) of Cote d'Ivoire and Expenses (% of total expenses) of Thailand?
Ensure brevity in your answer.  11.84. In the year 2011, what is the difference between the Expenses (% of total expenses) of Angola and Expenses (% of total expenses) of Australia?
Give a very brief answer. -4.65. In the year 2011, what is the difference between the Expenses (% of total expenses) in Angola and Expenses (% of total expenses) in Cote d'Ivoire?
Keep it short and to the point. -9.73. In the year 2011, what is the difference between the Expenses (% of total expenses) of Angola and Expenses (% of total expenses) of Thailand?
Ensure brevity in your answer.  -5.65. In the year 2011, what is the difference between the Expenses (% of total expenses) in Australia and Expenses (% of total expenses) in Cote d'Ivoire?
Your answer should be compact. -5.08. In the year 2011, what is the difference between the Expenses (% of total expenses) of Australia and Expenses (% of total expenses) of Thailand?
Offer a very short reply. -1. In the year 2011, what is the difference between the Expenses (% of total expenses) of Cote d'Ivoire and Expenses (% of total expenses) of Thailand?
Your response must be concise. 4.08. In the year 2012, what is the difference between the Expenses (% of total expenses) of Angola and Expenses (% of total expenses) of Australia?
Give a very brief answer. -5.38. In the year 2012, what is the difference between the Expenses (% of total expenses) of Angola and Expenses (% of total expenses) of Cote d'Ivoire?
Provide a short and direct response. -9.62. In the year 2012, what is the difference between the Expenses (% of total expenses) of Angola and Expenses (% of total expenses) of Thailand?
Make the answer very short. -5.67. In the year 2012, what is the difference between the Expenses (% of total expenses) of Australia and Expenses (% of total expenses) of Cote d'Ivoire?
Your response must be concise. -4.23. In the year 2012, what is the difference between the Expenses (% of total expenses) in Australia and Expenses (% of total expenses) in Thailand?
Make the answer very short. -0.28. In the year 2012, what is the difference between the Expenses (% of total expenses) in Cote d'Ivoire and Expenses (% of total expenses) in Thailand?
Give a very brief answer. 3.95. What is the ratio of the Expenses (% of total expenses) in Angola in 2006 to that in 2007?
Your answer should be very brief. 1.32. What is the ratio of the Expenses (% of total expenses) of Australia in 2006 to that in 2007?
Make the answer very short. 0.94. What is the ratio of the Expenses (% of total expenses) of Cote d'Ivoire in 2006 to that in 2007?
Ensure brevity in your answer.  0.95. What is the ratio of the Expenses (% of total expenses) in Thailand in 2006 to that in 2007?
Your answer should be compact. 1.49. What is the ratio of the Expenses (% of total expenses) in Angola in 2006 to that in 2008?
Give a very brief answer. 1.74. What is the ratio of the Expenses (% of total expenses) of Australia in 2006 to that in 2008?
Offer a terse response. 0.96. What is the ratio of the Expenses (% of total expenses) in Cote d'Ivoire in 2006 to that in 2008?
Provide a short and direct response. 0.81. What is the ratio of the Expenses (% of total expenses) in Thailand in 2006 to that in 2008?
Offer a very short reply. 1.06. What is the ratio of the Expenses (% of total expenses) of Angola in 2006 to that in 2009?
Offer a terse response. 2.48. What is the ratio of the Expenses (% of total expenses) of Australia in 2006 to that in 2009?
Offer a very short reply. 1.04. What is the ratio of the Expenses (% of total expenses) of Cote d'Ivoire in 2006 to that in 2009?
Your answer should be compact. 0.42. What is the ratio of the Expenses (% of total expenses) in Thailand in 2006 to that in 2009?
Keep it short and to the point. 1.5. What is the ratio of the Expenses (% of total expenses) of Angola in 2006 to that in 2010?
Provide a succinct answer. 2.77. What is the ratio of the Expenses (% of total expenses) of Australia in 2006 to that in 2010?
Your answer should be compact. 0.88. What is the ratio of the Expenses (% of total expenses) in Cote d'Ivoire in 2006 to that in 2010?
Ensure brevity in your answer.  0.43. What is the ratio of the Expenses (% of total expenses) in Thailand in 2006 to that in 2010?
Your response must be concise. 1.29. What is the ratio of the Expenses (% of total expenses) in Angola in 2006 to that in 2011?
Provide a short and direct response. 2.92. What is the ratio of the Expenses (% of total expenses) in Australia in 2006 to that in 2011?
Give a very brief answer. 1.01. What is the ratio of the Expenses (% of total expenses) of Cote d'Ivoire in 2006 to that in 2011?
Offer a terse response. 0.61. What is the ratio of the Expenses (% of total expenses) in Thailand in 2006 to that in 2011?
Your answer should be compact. 0.62. What is the ratio of the Expenses (% of total expenses) of Angola in 2006 to that in 2012?
Keep it short and to the point. 2.43. What is the ratio of the Expenses (% of total expenses) in Australia in 2006 to that in 2012?
Keep it short and to the point. 0.87. What is the ratio of the Expenses (% of total expenses) in Cote d'Ivoire in 2006 to that in 2012?
Give a very brief answer. 0.6. What is the ratio of the Expenses (% of total expenses) of Thailand in 2006 to that in 2012?
Offer a terse response. 0.6. What is the ratio of the Expenses (% of total expenses) of Angola in 2007 to that in 2008?
Your response must be concise. 1.31. What is the ratio of the Expenses (% of total expenses) in Australia in 2007 to that in 2008?
Provide a short and direct response. 1.02. What is the ratio of the Expenses (% of total expenses) of Cote d'Ivoire in 2007 to that in 2008?
Ensure brevity in your answer.  0.86. What is the ratio of the Expenses (% of total expenses) of Thailand in 2007 to that in 2008?
Your answer should be compact. 0.71. What is the ratio of the Expenses (% of total expenses) in Angola in 2007 to that in 2009?
Keep it short and to the point. 1.87. What is the ratio of the Expenses (% of total expenses) of Australia in 2007 to that in 2009?
Provide a succinct answer. 1.1. What is the ratio of the Expenses (% of total expenses) in Cote d'Ivoire in 2007 to that in 2009?
Provide a succinct answer. 0.44. What is the ratio of the Expenses (% of total expenses) of Angola in 2007 to that in 2010?
Your answer should be compact. 2.09. What is the ratio of the Expenses (% of total expenses) of Australia in 2007 to that in 2010?
Provide a short and direct response. 0.94. What is the ratio of the Expenses (% of total expenses) of Cote d'Ivoire in 2007 to that in 2010?
Keep it short and to the point. 0.46. What is the ratio of the Expenses (% of total expenses) of Thailand in 2007 to that in 2010?
Keep it short and to the point. 0.87. What is the ratio of the Expenses (% of total expenses) of Angola in 2007 to that in 2011?
Offer a terse response. 2.21. What is the ratio of the Expenses (% of total expenses) in Australia in 2007 to that in 2011?
Offer a terse response. 1.07. What is the ratio of the Expenses (% of total expenses) of Cote d'Ivoire in 2007 to that in 2011?
Provide a short and direct response. 0.64. What is the ratio of the Expenses (% of total expenses) in Thailand in 2007 to that in 2011?
Offer a very short reply. 0.42. What is the ratio of the Expenses (% of total expenses) of Angola in 2007 to that in 2012?
Keep it short and to the point. 1.84. What is the ratio of the Expenses (% of total expenses) in Australia in 2007 to that in 2012?
Your response must be concise. 0.92. What is the ratio of the Expenses (% of total expenses) of Cote d'Ivoire in 2007 to that in 2012?
Give a very brief answer. 0.64. What is the ratio of the Expenses (% of total expenses) in Thailand in 2007 to that in 2012?
Offer a terse response. 0.41. What is the ratio of the Expenses (% of total expenses) of Angola in 2008 to that in 2009?
Give a very brief answer. 1.43. What is the ratio of the Expenses (% of total expenses) in Australia in 2008 to that in 2009?
Make the answer very short. 1.08. What is the ratio of the Expenses (% of total expenses) of Cote d'Ivoire in 2008 to that in 2009?
Provide a succinct answer. 0.51. What is the ratio of the Expenses (% of total expenses) in Thailand in 2008 to that in 2009?
Provide a short and direct response. 1.41. What is the ratio of the Expenses (% of total expenses) of Angola in 2008 to that in 2010?
Offer a very short reply. 1.59. What is the ratio of the Expenses (% of total expenses) of Australia in 2008 to that in 2010?
Provide a short and direct response. 0.92. What is the ratio of the Expenses (% of total expenses) in Cote d'Ivoire in 2008 to that in 2010?
Provide a succinct answer. 0.53. What is the ratio of the Expenses (% of total expenses) in Thailand in 2008 to that in 2010?
Offer a terse response. 1.22. What is the ratio of the Expenses (% of total expenses) of Angola in 2008 to that in 2011?
Keep it short and to the point. 1.68. What is the ratio of the Expenses (% of total expenses) of Australia in 2008 to that in 2011?
Offer a very short reply. 1.06. What is the ratio of the Expenses (% of total expenses) of Cote d'Ivoire in 2008 to that in 2011?
Your response must be concise. 0.75. What is the ratio of the Expenses (% of total expenses) in Thailand in 2008 to that in 2011?
Provide a short and direct response. 0.59. What is the ratio of the Expenses (% of total expenses) in Angola in 2008 to that in 2012?
Provide a short and direct response. 1.4. What is the ratio of the Expenses (% of total expenses) in Australia in 2008 to that in 2012?
Your answer should be compact. 0.91. What is the ratio of the Expenses (% of total expenses) in Cote d'Ivoire in 2008 to that in 2012?
Your answer should be compact. 0.74. What is the ratio of the Expenses (% of total expenses) in Thailand in 2008 to that in 2012?
Keep it short and to the point. 0.57. What is the ratio of the Expenses (% of total expenses) of Angola in 2009 to that in 2010?
Offer a very short reply. 1.12. What is the ratio of the Expenses (% of total expenses) in Australia in 2009 to that in 2010?
Provide a succinct answer. 0.85. What is the ratio of the Expenses (% of total expenses) in Cote d'Ivoire in 2009 to that in 2010?
Your response must be concise. 1.04. What is the ratio of the Expenses (% of total expenses) in Thailand in 2009 to that in 2010?
Your answer should be compact. 0.87. What is the ratio of the Expenses (% of total expenses) of Angola in 2009 to that in 2011?
Provide a short and direct response. 1.18. What is the ratio of the Expenses (% of total expenses) of Australia in 2009 to that in 2011?
Your response must be concise. 0.98. What is the ratio of the Expenses (% of total expenses) of Cote d'Ivoire in 2009 to that in 2011?
Give a very brief answer. 1.46. What is the ratio of the Expenses (% of total expenses) in Thailand in 2009 to that in 2011?
Offer a terse response. 0.42. What is the ratio of the Expenses (% of total expenses) of Angola in 2009 to that in 2012?
Provide a succinct answer. 0.98. What is the ratio of the Expenses (% of total expenses) in Australia in 2009 to that in 2012?
Ensure brevity in your answer.  0.84. What is the ratio of the Expenses (% of total expenses) in Cote d'Ivoire in 2009 to that in 2012?
Your answer should be compact. 1.45. What is the ratio of the Expenses (% of total expenses) in Thailand in 2009 to that in 2012?
Offer a terse response. 0.4. What is the ratio of the Expenses (% of total expenses) of Angola in 2010 to that in 2011?
Give a very brief answer. 1.06. What is the ratio of the Expenses (% of total expenses) of Australia in 2010 to that in 2011?
Give a very brief answer. 1.15. What is the ratio of the Expenses (% of total expenses) in Cote d'Ivoire in 2010 to that in 2011?
Your answer should be very brief. 1.41. What is the ratio of the Expenses (% of total expenses) in Thailand in 2010 to that in 2011?
Offer a very short reply. 0.48. What is the ratio of the Expenses (% of total expenses) of Angola in 2010 to that in 2012?
Provide a short and direct response. 0.88. What is the ratio of the Expenses (% of total expenses) of Australia in 2010 to that in 2012?
Offer a terse response. 0.99. What is the ratio of the Expenses (% of total expenses) of Cote d'Ivoire in 2010 to that in 2012?
Your answer should be compact. 1.4. What is the ratio of the Expenses (% of total expenses) in Thailand in 2010 to that in 2012?
Provide a succinct answer. 0.47. What is the ratio of the Expenses (% of total expenses) of Angola in 2011 to that in 2012?
Give a very brief answer. 0.83. What is the ratio of the Expenses (% of total expenses) in Australia in 2011 to that in 2012?
Your response must be concise. 0.86. What is the ratio of the Expenses (% of total expenses) in Cote d'Ivoire in 2011 to that in 2012?
Keep it short and to the point. 0.99. What is the ratio of the Expenses (% of total expenses) in Thailand in 2011 to that in 2012?
Provide a succinct answer. 0.97. What is the difference between the highest and the second highest Expenses (% of total expenses) of Angola?
Ensure brevity in your answer.  0.68. What is the difference between the highest and the second highest Expenses (% of total expenses) of Australia?
Give a very brief answer. 0.1. What is the difference between the highest and the second highest Expenses (% of total expenses) in Cote d'Ivoire?
Your answer should be compact. 0.62. What is the difference between the highest and the second highest Expenses (% of total expenses) of Thailand?
Provide a succinct answer. 0.21. What is the difference between the highest and the lowest Expenses (% of total expenses) in Angola?
Provide a short and direct response. 1.83. What is the difference between the highest and the lowest Expenses (% of total expenses) of Australia?
Your answer should be very brief. 1.06. What is the difference between the highest and the lowest Expenses (% of total expenses) of Cote d'Ivoire?
Your response must be concise. 9.13. What is the difference between the highest and the lowest Expenses (% of total expenses) of Thailand?
Ensure brevity in your answer.  4.06. 